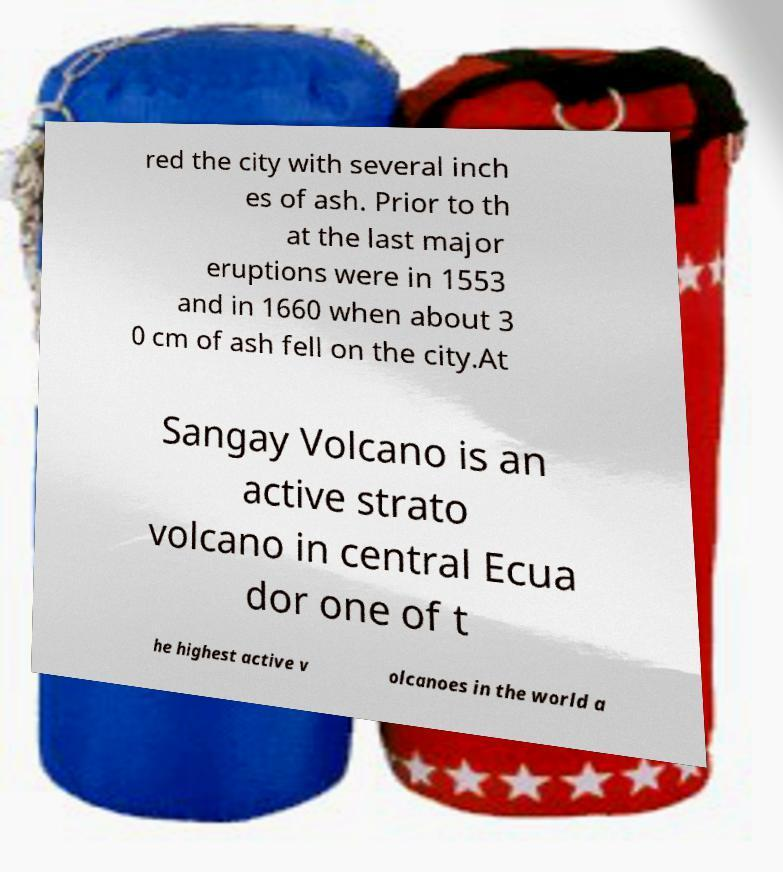There's text embedded in this image that I need extracted. Can you transcribe it verbatim? red the city with several inch es of ash. Prior to th at the last major eruptions were in 1553 and in 1660 when about 3 0 cm of ash fell on the city.At Sangay Volcano is an active strato volcano in central Ecua dor one of t he highest active v olcanoes in the world a 